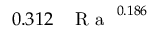<formula> <loc_0><loc_0><loc_500><loc_500>0 . 3 1 2 \, { R a } ^ { 0 . 1 8 6 }</formula> 